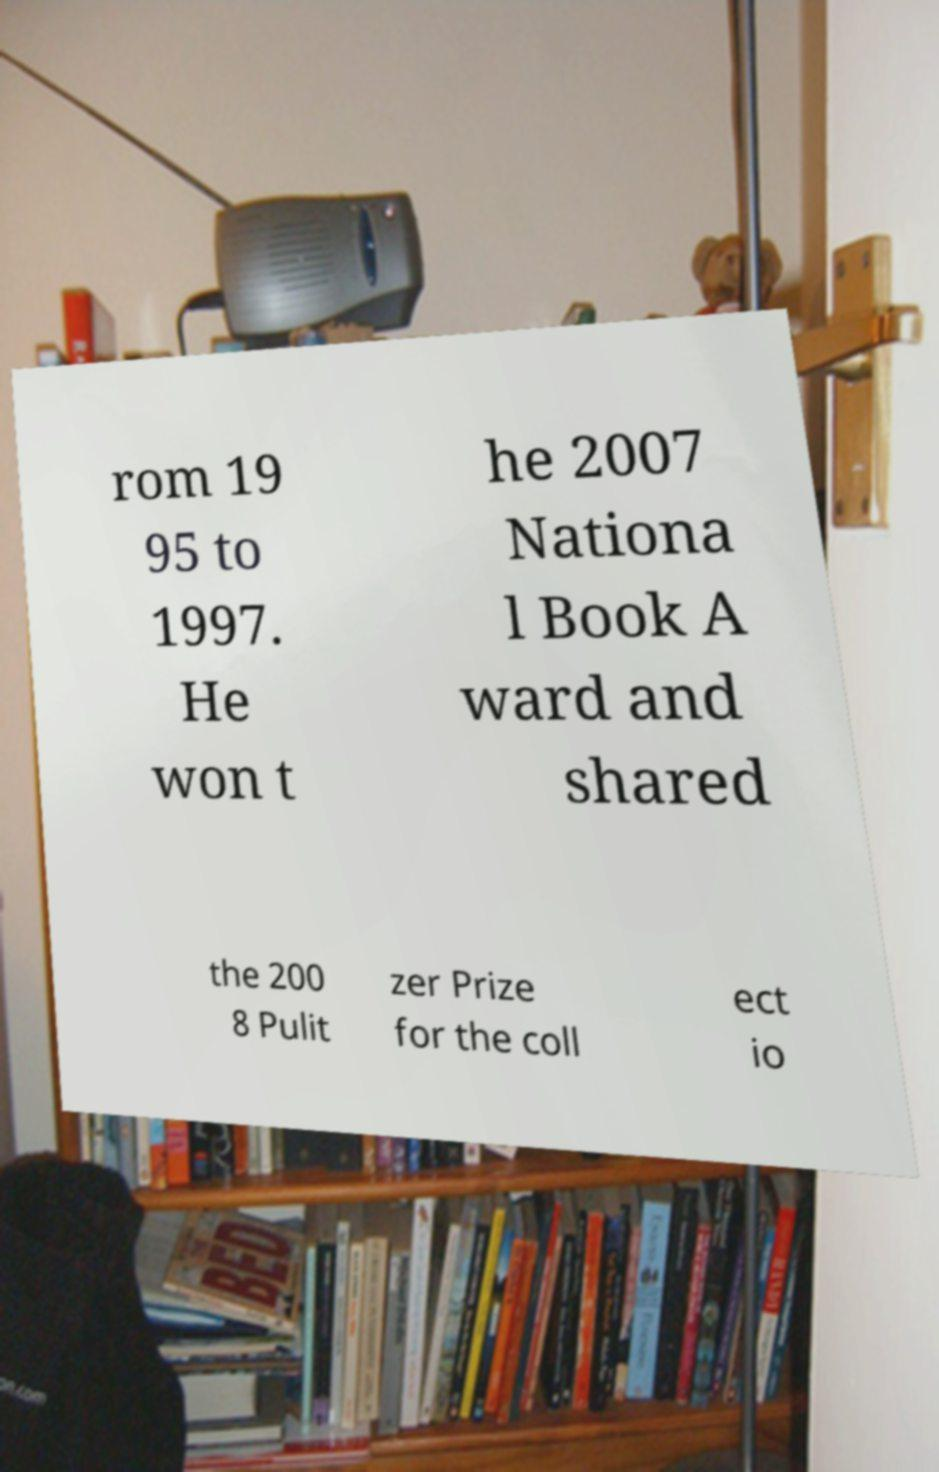Could you assist in decoding the text presented in this image and type it out clearly? rom 19 95 to 1997. He won t he 2007 Nationa l Book A ward and shared the 200 8 Pulit zer Prize for the coll ect io 